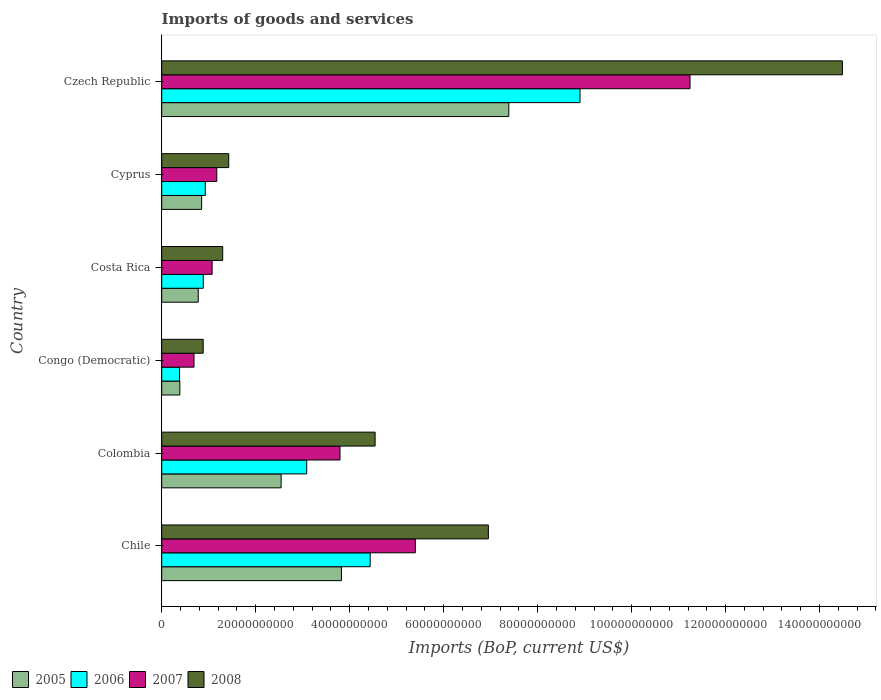How many different coloured bars are there?
Give a very brief answer. 4. How many groups of bars are there?
Give a very brief answer. 6. Are the number of bars per tick equal to the number of legend labels?
Ensure brevity in your answer.  Yes. How many bars are there on the 3rd tick from the top?
Your response must be concise. 4. What is the label of the 4th group of bars from the top?
Offer a very short reply. Congo (Democratic). What is the amount spent on imports in 2007 in Czech Republic?
Your response must be concise. 1.12e+11. Across all countries, what is the maximum amount spent on imports in 2006?
Give a very brief answer. 8.90e+1. Across all countries, what is the minimum amount spent on imports in 2006?
Provide a succinct answer. 3.80e+09. In which country was the amount spent on imports in 2006 maximum?
Provide a succinct answer. Czech Republic. In which country was the amount spent on imports in 2007 minimum?
Ensure brevity in your answer.  Congo (Democratic). What is the total amount spent on imports in 2008 in the graph?
Your response must be concise. 2.96e+11. What is the difference between the amount spent on imports in 2006 in Cyprus and that in Czech Republic?
Keep it short and to the point. -7.97e+1. What is the difference between the amount spent on imports in 2006 in Congo (Democratic) and the amount spent on imports in 2008 in Cyprus?
Your answer should be compact. -1.05e+1. What is the average amount spent on imports in 2008 per country?
Your answer should be very brief. 4.93e+1. What is the difference between the amount spent on imports in 2008 and amount spent on imports in 2005 in Colombia?
Offer a very short reply. 2.00e+1. In how many countries, is the amount spent on imports in 2008 greater than 136000000000 US$?
Keep it short and to the point. 1. What is the ratio of the amount spent on imports in 2008 in Chile to that in Congo (Democratic)?
Keep it short and to the point. 7.88. Is the amount spent on imports in 2006 in Costa Rica less than that in Czech Republic?
Make the answer very short. Yes. Is the difference between the amount spent on imports in 2008 in Chile and Costa Rica greater than the difference between the amount spent on imports in 2005 in Chile and Costa Rica?
Provide a short and direct response. Yes. What is the difference between the highest and the second highest amount spent on imports in 2006?
Provide a short and direct response. 4.47e+1. What is the difference between the highest and the lowest amount spent on imports in 2005?
Your response must be concise. 7.00e+1. Is the sum of the amount spent on imports in 2005 in Chile and Congo (Democratic) greater than the maximum amount spent on imports in 2008 across all countries?
Offer a terse response. No. What does the 1st bar from the top in Cyprus represents?
Ensure brevity in your answer.  2008. What does the 2nd bar from the bottom in Colombia represents?
Offer a very short reply. 2006. Is it the case that in every country, the sum of the amount spent on imports in 2006 and amount spent on imports in 2007 is greater than the amount spent on imports in 2008?
Provide a succinct answer. Yes. How many bars are there?
Your answer should be compact. 24. Are all the bars in the graph horizontal?
Your response must be concise. Yes. How many legend labels are there?
Your answer should be very brief. 4. How are the legend labels stacked?
Provide a short and direct response. Horizontal. What is the title of the graph?
Provide a succinct answer. Imports of goods and services. Does "1973" appear as one of the legend labels in the graph?
Ensure brevity in your answer.  No. What is the label or title of the X-axis?
Provide a short and direct response. Imports (BoP, current US$). What is the label or title of the Y-axis?
Provide a succinct answer. Country. What is the Imports (BoP, current US$) of 2005 in Chile?
Offer a terse response. 3.82e+1. What is the Imports (BoP, current US$) of 2006 in Chile?
Your answer should be compact. 4.44e+1. What is the Imports (BoP, current US$) in 2007 in Chile?
Keep it short and to the point. 5.40e+1. What is the Imports (BoP, current US$) in 2008 in Chile?
Give a very brief answer. 6.95e+1. What is the Imports (BoP, current US$) in 2005 in Colombia?
Give a very brief answer. 2.54e+1. What is the Imports (BoP, current US$) of 2006 in Colombia?
Ensure brevity in your answer.  3.09e+1. What is the Imports (BoP, current US$) in 2007 in Colombia?
Give a very brief answer. 3.79e+1. What is the Imports (BoP, current US$) in 2008 in Colombia?
Your answer should be compact. 4.54e+1. What is the Imports (BoP, current US$) of 2005 in Congo (Democratic)?
Offer a very short reply. 3.86e+09. What is the Imports (BoP, current US$) in 2006 in Congo (Democratic)?
Your answer should be compact. 3.80e+09. What is the Imports (BoP, current US$) of 2007 in Congo (Democratic)?
Make the answer very short. 6.87e+09. What is the Imports (BoP, current US$) in 2008 in Congo (Democratic)?
Make the answer very short. 8.83e+09. What is the Imports (BoP, current US$) in 2005 in Costa Rica?
Keep it short and to the point. 7.77e+09. What is the Imports (BoP, current US$) of 2006 in Costa Rica?
Keep it short and to the point. 8.85e+09. What is the Imports (BoP, current US$) of 2007 in Costa Rica?
Your answer should be compact. 1.07e+1. What is the Imports (BoP, current US$) of 2008 in Costa Rica?
Your response must be concise. 1.30e+1. What is the Imports (BoP, current US$) of 2005 in Cyprus?
Give a very brief answer. 8.50e+09. What is the Imports (BoP, current US$) of 2006 in Cyprus?
Your answer should be very brief. 9.27e+09. What is the Imports (BoP, current US$) in 2007 in Cyprus?
Your answer should be very brief. 1.17e+1. What is the Imports (BoP, current US$) in 2008 in Cyprus?
Your response must be concise. 1.43e+1. What is the Imports (BoP, current US$) in 2005 in Czech Republic?
Give a very brief answer. 7.39e+1. What is the Imports (BoP, current US$) in 2006 in Czech Republic?
Keep it short and to the point. 8.90e+1. What is the Imports (BoP, current US$) in 2007 in Czech Republic?
Offer a very short reply. 1.12e+11. What is the Imports (BoP, current US$) of 2008 in Czech Republic?
Provide a short and direct response. 1.45e+11. Across all countries, what is the maximum Imports (BoP, current US$) in 2005?
Provide a succinct answer. 7.39e+1. Across all countries, what is the maximum Imports (BoP, current US$) of 2006?
Provide a succinct answer. 8.90e+1. Across all countries, what is the maximum Imports (BoP, current US$) of 2007?
Make the answer very short. 1.12e+11. Across all countries, what is the maximum Imports (BoP, current US$) in 2008?
Offer a very short reply. 1.45e+11. Across all countries, what is the minimum Imports (BoP, current US$) in 2005?
Provide a short and direct response. 3.86e+09. Across all countries, what is the minimum Imports (BoP, current US$) in 2006?
Keep it short and to the point. 3.80e+09. Across all countries, what is the minimum Imports (BoP, current US$) in 2007?
Your answer should be compact. 6.87e+09. Across all countries, what is the minimum Imports (BoP, current US$) in 2008?
Your response must be concise. 8.83e+09. What is the total Imports (BoP, current US$) in 2005 in the graph?
Offer a terse response. 1.58e+11. What is the total Imports (BoP, current US$) of 2006 in the graph?
Offer a terse response. 1.86e+11. What is the total Imports (BoP, current US$) of 2007 in the graph?
Provide a succinct answer. 2.34e+11. What is the total Imports (BoP, current US$) in 2008 in the graph?
Provide a short and direct response. 2.96e+11. What is the difference between the Imports (BoP, current US$) of 2005 in Chile and that in Colombia?
Your response must be concise. 1.28e+1. What is the difference between the Imports (BoP, current US$) in 2006 in Chile and that in Colombia?
Provide a succinct answer. 1.35e+1. What is the difference between the Imports (BoP, current US$) of 2007 in Chile and that in Colombia?
Offer a terse response. 1.60e+1. What is the difference between the Imports (BoP, current US$) in 2008 in Chile and that in Colombia?
Your response must be concise. 2.41e+1. What is the difference between the Imports (BoP, current US$) in 2005 in Chile and that in Congo (Democratic)?
Offer a terse response. 3.44e+1. What is the difference between the Imports (BoP, current US$) in 2006 in Chile and that in Congo (Democratic)?
Your response must be concise. 4.06e+1. What is the difference between the Imports (BoP, current US$) of 2007 in Chile and that in Congo (Democratic)?
Offer a very short reply. 4.71e+1. What is the difference between the Imports (BoP, current US$) of 2008 in Chile and that in Congo (Democratic)?
Your response must be concise. 6.07e+1. What is the difference between the Imports (BoP, current US$) of 2005 in Chile and that in Costa Rica?
Your response must be concise. 3.05e+1. What is the difference between the Imports (BoP, current US$) of 2006 in Chile and that in Costa Rica?
Offer a very short reply. 3.55e+1. What is the difference between the Imports (BoP, current US$) in 2007 in Chile and that in Costa Rica?
Ensure brevity in your answer.  4.33e+1. What is the difference between the Imports (BoP, current US$) of 2008 in Chile and that in Costa Rica?
Ensure brevity in your answer.  5.65e+1. What is the difference between the Imports (BoP, current US$) in 2005 in Chile and that in Cyprus?
Offer a terse response. 2.98e+1. What is the difference between the Imports (BoP, current US$) of 2006 in Chile and that in Cyprus?
Provide a succinct answer. 3.51e+1. What is the difference between the Imports (BoP, current US$) of 2007 in Chile and that in Cyprus?
Your response must be concise. 4.23e+1. What is the difference between the Imports (BoP, current US$) in 2008 in Chile and that in Cyprus?
Your answer should be compact. 5.53e+1. What is the difference between the Imports (BoP, current US$) in 2005 in Chile and that in Czech Republic?
Your answer should be compact. -3.56e+1. What is the difference between the Imports (BoP, current US$) of 2006 in Chile and that in Czech Republic?
Your answer should be very brief. -4.47e+1. What is the difference between the Imports (BoP, current US$) of 2007 in Chile and that in Czech Republic?
Give a very brief answer. -5.85e+1. What is the difference between the Imports (BoP, current US$) of 2008 in Chile and that in Czech Republic?
Your answer should be compact. -7.54e+1. What is the difference between the Imports (BoP, current US$) of 2005 in Colombia and that in Congo (Democratic)?
Provide a short and direct response. 2.16e+1. What is the difference between the Imports (BoP, current US$) of 2006 in Colombia and that in Congo (Democratic)?
Your answer should be very brief. 2.71e+1. What is the difference between the Imports (BoP, current US$) in 2007 in Colombia and that in Congo (Democratic)?
Your answer should be compact. 3.11e+1. What is the difference between the Imports (BoP, current US$) in 2008 in Colombia and that in Congo (Democratic)?
Provide a succinct answer. 3.66e+1. What is the difference between the Imports (BoP, current US$) in 2005 in Colombia and that in Costa Rica?
Your answer should be compact. 1.76e+1. What is the difference between the Imports (BoP, current US$) in 2006 in Colombia and that in Costa Rica?
Offer a terse response. 2.20e+1. What is the difference between the Imports (BoP, current US$) of 2007 in Colombia and that in Costa Rica?
Give a very brief answer. 2.72e+1. What is the difference between the Imports (BoP, current US$) of 2008 in Colombia and that in Costa Rica?
Give a very brief answer. 3.24e+1. What is the difference between the Imports (BoP, current US$) in 2005 in Colombia and that in Cyprus?
Ensure brevity in your answer.  1.69e+1. What is the difference between the Imports (BoP, current US$) in 2006 in Colombia and that in Cyprus?
Keep it short and to the point. 2.16e+1. What is the difference between the Imports (BoP, current US$) of 2007 in Colombia and that in Cyprus?
Your answer should be very brief. 2.62e+1. What is the difference between the Imports (BoP, current US$) of 2008 in Colombia and that in Cyprus?
Your response must be concise. 3.12e+1. What is the difference between the Imports (BoP, current US$) in 2005 in Colombia and that in Czech Republic?
Offer a terse response. -4.85e+1. What is the difference between the Imports (BoP, current US$) of 2006 in Colombia and that in Czech Republic?
Your response must be concise. -5.82e+1. What is the difference between the Imports (BoP, current US$) in 2007 in Colombia and that in Czech Republic?
Your response must be concise. -7.45e+1. What is the difference between the Imports (BoP, current US$) of 2008 in Colombia and that in Czech Republic?
Offer a very short reply. -9.95e+1. What is the difference between the Imports (BoP, current US$) of 2005 in Congo (Democratic) and that in Costa Rica?
Your answer should be compact. -3.91e+09. What is the difference between the Imports (BoP, current US$) in 2006 in Congo (Democratic) and that in Costa Rica?
Your response must be concise. -5.05e+09. What is the difference between the Imports (BoP, current US$) in 2007 in Congo (Democratic) and that in Costa Rica?
Your answer should be compact. -3.85e+09. What is the difference between the Imports (BoP, current US$) in 2008 in Congo (Democratic) and that in Costa Rica?
Provide a succinct answer. -4.15e+09. What is the difference between the Imports (BoP, current US$) in 2005 in Congo (Democratic) and that in Cyprus?
Make the answer very short. -4.64e+09. What is the difference between the Imports (BoP, current US$) in 2006 in Congo (Democratic) and that in Cyprus?
Offer a very short reply. -5.48e+09. What is the difference between the Imports (BoP, current US$) of 2007 in Congo (Democratic) and that in Cyprus?
Provide a short and direct response. -4.85e+09. What is the difference between the Imports (BoP, current US$) of 2008 in Congo (Democratic) and that in Cyprus?
Your answer should be compact. -5.44e+09. What is the difference between the Imports (BoP, current US$) of 2005 in Congo (Democratic) and that in Czech Republic?
Provide a short and direct response. -7.00e+1. What is the difference between the Imports (BoP, current US$) in 2006 in Congo (Democratic) and that in Czech Republic?
Keep it short and to the point. -8.52e+1. What is the difference between the Imports (BoP, current US$) in 2007 in Congo (Democratic) and that in Czech Republic?
Your answer should be compact. -1.06e+11. What is the difference between the Imports (BoP, current US$) of 2008 in Congo (Democratic) and that in Czech Republic?
Provide a succinct answer. -1.36e+11. What is the difference between the Imports (BoP, current US$) of 2005 in Costa Rica and that in Cyprus?
Provide a short and direct response. -7.27e+08. What is the difference between the Imports (BoP, current US$) in 2006 in Costa Rica and that in Cyprus?
Your answer should be very brief. -4.28e+08. What is the difference between the Imports (BoP, current US$) in 2007 in Costa Rica and that in Cyprus?
Your response must be concise. -9.93e+08. What is the difference between the Imports (BoP, current US$) in 2008 in Costa Rica and that in Cyprus?
Give a very brief answer. -1.29e+09. What is the difference between the Imports (BoP, current US$) of 2005 in Costa Rica and that in Czech Republic?
Your answer should be very brief. -6.61e+1. What is the difference between the Imports (BoP, current US$) of 2006 in Costa Rica and that in Czech Republic?
Provide a succinct answer. -8.02e+1. What is the difference between the Imports (BoP, current US$) of 2007 in Costa Rica and that in Czech Republic?
Offer a very short reply. -1.02e+11. What is the difference between the Imports (BoP, current US$) of 2008 in Costa Rica and that in Czech Republic?
Provide a succinct answer. -1.32e+11. What is the difference between the Imports (BoP, current US$) in 2005 in Cyprus and that in Czech Republic?
Your answer should be very brief. -6.54e+1. What is the difference between the Imports (BoP, current US$) in 2006 in Cyprus and that in Czech Republic?
Give a very brief answer. -7.97e+1. What is the difference between the Imports (BoP, current US$) in 2007 in Cyprus and that in Czech Republic?
Give a very brief answer. -1.01e+11. What is the difference between the Imports (BoP, current US$) in 2008 in Cyprus and that in Czech Republic?
Keep it short and to the point. -1.31e+11. What is the difference between the Imports (BoP, current US$) of 2005 in Chile and the Imports (BoP, current US$) of 2006 in Colombia?
Your answer should be very brief. 7.40e+09. What is the difference between the Imports (BoP, current US$) in 2005 in Chile and the Imports (BoP, current US$) in 2007 in Colombia?
Offer a very short reply. 3.07e+08. What is the difference between the Imports (BoP, current US$) in 2005 in Chile and the Imports (BoP, current US$) in 2008 in Colombia?
Ensure brevity in your answer.  -7.17e+09. What is the difference between the Imports (BoP, current US$) of 2006 in Chile and the Imports (BoP, current US$) of 2007 in Colombia?
Provide a short and direct response. 6.42e+09. What is the difference between the Imports (BoP, current US$) in 2006 in Chile and the Imports (BoP, current US$) in 2008 in Colombia?
Your answer should be very brief. -1.05e+09. What is the difference between the Imports (BoP, current US$) of 2007 in Chile and the Imports (BoP, current US$) of 2008 in Colombia?
Your response must be concise. 8.57e+09. What is the difference between the Imports (BoP, current US$) of 2005 in Chile and the Imports (BoP, current US$) of 2006 in Congo (Democratic)?
Provide a short and direct response. 3.45e+1. What is the difference between the Imports (BoP, current US$) in 2005 in Chile and the Imports (BoP, current US$) in 2007 in Congo (Democratic)?
Make the answer very short. 3.14e+1. What is the difference between the Imports (BoP, current US$) in 2005 in Chile and the Imports (BoP, current US$) in 2008 in Congo (Democratic)?
Offer a terse response. 2.94e+1. What is the difference between the Imports (BoP, current US$) of 2006 in Chile and the Imports (BoP, current US$) of 2007 in Congo (Democratic)?
Provide a short and direct response. 3.75e+1. What is the difference between the Imports (BoP, current US$) of 2006 in Chile and the Imports (BoP, current US$) of 2008 in Congo (Democratic)?
Offer a terse response. 3.55e+1. What is the difference between the Imports (BoP, current US$) of 2007 in Chile and the Imports (BoP, current US$) of 2008 in Congo (Democratic)?
Your response must be concise. 4.52e+1. What is the difference between the Imports (BoP, current US$) in 2005 in Chile and the Imports (BoP, current US$) in 2006 in Costa Rica?
Provide a short and direct response. 2.94e+1. What is the difference between the Imports (BoP, current US$) in 2005 in Chile and the Imports (BoP, current US$) in 2007 in Costa Rica?
Ensure brevity in your answer.  2.75e+1. What is the difference between the Imports (BoP, current US$) of 2005 in Chile and the Imports (BoP, current US$) of 2008 in Costa Rica?
Your response must be concise. 2.53e+1. What is the difference between the Imports (BoP, current US$) of 2006 in Chile and the Imports (BoP, current US$) of 2007 in Costa Rica?
Offer a terse response. 3.36e+1. What is the difference between the Imports (BoP, current US$) in 2006 in Chile and the Imports (BoP, current US$) in 2008 in Costa Rica?
Offer a very short reply. 3.14e+1. What is the difference between the Imports (BoP, current US$) in 2007 in Chile and the Imports (BoP, current US$) in 2008 in Costa Rica?
Your response must be concise. 4.10e+1. What is the difference between the Imports (BoP, current US$) in 2005 in Chile and the Imports (BoP, current US$) in 2006 in Cyprus?
Offer a terse response. 2.90e+1. What is the difference between the Imports (BoP, current US$) of 2005 in Chile and the Imports (BoP, current US$) of 2007 in Cyprus?
Keep it short and to the point. 2.65e+1. What is the difference between the Imports (BoP, current US$) of 2005 in Chile and the Imports (BoP, current US$) of 2008 in Cyprus?
Offer a terse response. 2.40e+1. What is the difference between the Imports (BoP, current US$) in 2006 in Chile and the Imports (BoP, current US$) in 2007 in Cyprus?
Your answer should be compact. 3.26e+1. What is the difference between the Imports (BoP, current US$) of 2006 in Chile and the Imports (BoP, current US$) of 2008 in Cyprus?
Make the answer very short. 3.01e+1. What is the difference between the Imports (BoP, current US$) of 2007 in Chile and the Imports (BoP, current US$) of 2008 in Cyprus?
Your response must be concise. 3.97e+1. What is the difference between the Imports (BoP, current US$) in 2005 in Chile and the Imports (BoP, current US$) in 2006 in Czech Republic?
Ensure brevity in your answer.  -5.08e+1. What is the difference between the Imports (BoP, current US$) in 2005 in Chile and the Imports (BoP, current US$) in 2007 in Czech Republic?
Your response must be concise. -7.42e+1. What is the difference between the Imports (BoP, current US$) of 2005 in Chile and the Imports (BoP, current US$) of 2008 in Czech Republic?
Provide a succinct answer. -1.07e+11. What is the difference between the Imports (BoP, current US$) in 2006 in Chile and the Imports (BoP, current US$) in 2007 in Czech Republic?
Your answer should be very brief. -6.81e+1. What is the difference between the Imports (BoP, current US$) in 2006 in Chile and the Imports (BoP, current US$) in 2008 in Czech Republic?
Your answer should be very brief. -1.01e+11. What is the difference between the Imports (BoP, current US$) of 2007 in Chile and the Imports (BoP, current US$) of 2008 in Czech Republic?
Your response must be concise. -9.09e+1. What is the difference between the Imports (BoP, current US$) of 2005 in Colombia and the Imports (BoP, current US$) of 2006 in Congo (Democratic)?
Your answer should be very brief. 2.16e+1. What is the difference between the Imports (BoP, current US$) of 2005 in Colombia and the Imports (BoP, current US$) of 2007 in Congo (Democratic)?
Give a very brief answer. 1.85e+1. What is the difference between the Imports (BoP, current US$) in 2005 in Colombia and the Imports (BoP, current US$) in 2008 in Congo (Democratic)?
Make the answer very short. 1.66e+1. What is the difference between the Imports (BoP, current US$) of 2006 in Colombia and the Imports (BoP, current US$) of 2007 in Congo (Democratic)?
Provide a succinct answer. 2.40e+1. What is the difference between the Imports (BoP, current US$) of 2006 in Colombia and the Imports (BoP, current US$) of 2008 in Congo (Democratic)?
Offer a very short reply. 2.20e+1. What is the difference between the Imports (BoP, current US$) in 2007 in Colombia and the Imports (BoP, current US$) in 2008 in Congo (Democratic)?
Give a very brief answer. 2.91e+1. What is the difference between the Imports (BoP, current US$) of 2005 in Colombia and the Imports (BoP, current US$) of 2006 in Costa Rica?
Offer a terse response. 1.66e+1. What is the difference between the Imports (BoP, current US$) in 2005 in Colombia and the Imports (BoP, current US$) in 2007 in Costa Rica?
Provide a succinct answer. 1.47e+1. What is the difference between the Imports (BoP, current US$) in 2005 in Colombia and the Imports (BoP, current US$) in 2008 in Costa Rica?
Offer a very short reply. 1.24e+1. What is the difference between the Imports (BoP, current US$) in 2006 in Colombia and the Imports (BoP, current US$) in 2007 in Costa Rica?
Your response must be concise. 2.01e+1. What is the difference between the Imports (BoP, current US$) in 2006 in Colombia and the Imports (BoP, current US$) in 2008 in Costa Rica?
Offer a very short reply. 1.79e+1. What is the difference between the Imports (BoP, current US$) of 2007 in Colombia and the Imports (BoP, current US$) of 2008 in Costa Rica?
Offer a terse response. 2.50e+1. What is the difference between the Imports (BoP, current US$) of 2005 in Colombia and the Imports (BoP, current US$) of 2006 in Cyprus?
Keep it short and to the point. 1.61e+1. What is the difference between the Imports (BoP, current US$) in 2005 in Colombia and the Imports (BoP, current US$) in 2007 in Cyprus?
Provide a succinct answer. 1.37e+1. What is the difference between the Imports (BoP, current US$) of 2005 in Colombia and the Imports (BoP, current US$) of 2008 in Cyprus?
Make the answer very short. 1.11e+1. What is the difference between the Imports (BoP, current US$) of 2006 in Colombia and the Imports (BoP, current US$) of 2007 in Cyprus?
Ensure brevity in your answer.  1.91e+1. What is the difference between the Imports (BoP, current US$) of 2006 in Colombia and the Imports (BoP, current US$) of 2008 in Cyprus?
Offer a terse response. 1.66e+1. What is the difference between the Imports (BoP, current US$) in 2007 in Colombia and the Imports (BoP, current US$) in 2008 in Cyprus?
Ensure brevity in your answer.  2.37e+1. What is the difference between the Imports (BoP, current US$) of 2005 in Colombia and the Imports (BoP, current US$) of 2006 in Czech Republic?
Your answer should be compact. -6.36e+1. What is the difference between the Imports (BoP, current US$) of 2005 in Colombia and the Imports (BoP, current US$) of 2007 in Czech Republic?
Make the answer very short. -8.70e+1. What is the difference between the Imports (BoP, current US$) of 2005 in Colombia and the Imports (BoP, current US$) of 2008 in Czech Republic?
Ensure brevity in your answer.  -1.19e+11. What is the difference between the Imports (BoP, current US$) of 2006 in Colombia and the Imports (BoP, current US$) of 2007 in Czech Republic?
Provide a short and direct response. -8.16e+1. What is the difference between the Imports (BoP, current US$) of 2006 in Colombia and the Imports (BoP, current US$) of 2008 in Czech Republic?
Your answer should be compact. -1.14e+11. What is the difference between the Imports (BoP, current US$) in 2007 in Colombia and the Imports (BoP, current US$) in 2008 in Czech Republic?
Keep it short and to the point. -1.07e+11. What is the difference between the Imports (BoP, current US$) of 2005 in Congo (Democratic) and the Imports (BoP, current US$) of 2006 in Costa Rica?
Make the answer very short. -4.99e+09. What is the difference between the Imports (BoP, current US$) in 2005 in Congo (Democratic) and the Imports (BoP, current US$) in 2007 in Costa Rica?
Offer a very short reply. -6.87e+09. What is the difference between the Imports (BoP, current US$) in 2005 in Congo (Democratic) and the Imports (BoP, current US$) in 2008 in Costa Rica?
Give a very brief answer. -9.12e+09. What is the difference between the Imports (BoP, current US$) of 2006 in Congo (Democratic) and the Imports (BoP, current US$) of 2007 in Costa Rica?
Provide a succinct answer. -6.93e+09. What is the difference between the Imports (BoP, current US$) of 2006 in Congo (Democratic) and the Imports (BoP, current US$) of 2008 in Costa Rica?
Offer a terse response. -9.18e+09. What is the difference between the Imports (BoP, current US$) in 2007 in Congo (Democratic) and the Imports (BoP, current US$) in 2008 in Costa Rica?
Your response must be concise. -6.10e+09. What is the difference between the Imports (BoP, current US$) in 2005 in Congo (Democratic) and the Imports (BoP, current US$) in 2006 in Cyprus?
Your answer should be very brief. -5.41e+09. What is the difference between the Imports (BoP, current US$) of 2005 in Congo (Democratic) and the Imports (BoP, current US$) of 2007 in Cyprus?
Your answer should be very brief. -7.86e+09. What is the difference between the Imports (BoP, current US$) of 2005 in Congo (Democratic) and the Imports (BoP, current US$) of 2008 in Cyprus?
Keep it short and to the point. -1.04e+1. What is the difference between the Imports (BoP, current US$) of 2006 in Congo (Democratic) and the Imports (BoP, current US$) of 2007 in Cyprus?
Provide a short and direct response. -7.92e+09. What is the difference between the Imports (BoP, current US$) in 2006 in Congo (Democratic) and the Imports (BoP, current US$) in 2008 in Cyprus?
Your answer should be very brief. -1.05e+1. What is the difference between the Imports (BoP, current US$) of 2007 in Congo (Democratic) and the Imports (BoP, current US$) of 2008 in Cyprus?
Ensure brevity in your answer.  -7.39e+09. What is the difference between the Imports (BoP, current US$) in 2005 in Congo (Democratic) and the Imports (BoP, current US$) in 2006 in Czech Republic?
Provide a short and direct response. -8.52e+1. What is the difference between the Imports (BoP, current US$) in 2005 in Congo (Democratic) and the Imports (BoP, current US$) in 2007 in Czech Republic?
Your answer should be very brief. -1.09e+11. What is the difference between the Imports (BoP, current US$) in 2005 in Congo (Democratic) and the Imports (BoP, current US$) in 2008 in Czech Republic?
Give a very brief answer. -1.41e+11. What is the difference between the Imports (BoP, current US$) in 2006 in Congo (Democratic) and the Imports (BoP, current US$) in 2007 in Czech Republic?
Make the answer very short. -1.09e+11. What is the difference between the Imports (BoP, current US$) of 2006 in Congo (Democratic) and the Imports (BoP, current US$) of 2008 in Czech Republic?
Provide a succinct answer. -1.41e+11. What is the difference between the Imports (BoP, current US$) of 2007 in Congo (Democratic) and the Imports (BoP, current US$) of 2008 in Czech Republic?
Your response must be concise. -1.38e+11. What is the difference between the Imports (BoP, current US$) of 2005 in Costa Rica and the Imports (BoP, current US$) of 2006 in Cyprus?
Keep it short and to the point. -1.50e+09. What is the difference between the Imports (BoP, current US$) in 2005 in Costa Rica and the Imports (BoP, current US$) in 2007 in Cyprus?
Your answer should be very brief. -3.95e+09. What is the difference between the Imports (BoP, current US$) of 2005 in Costa Rica and the Imports (BoP, current US$) of 2008 in Cyprus?
Your answer should be compact. -6.49e+09. What is the difference between the Imports (BoP, current US$) of 2006 in Costa Rica and the Imports (BoP, current US$) of 2007 in Cyprus?
Ensure brevity in your answer.  -2.88e+09. What is the difference between the Imports (BoP, current US$) in 2006 in Costa Rica and the Imports (BoP, current US$) in 2008 in Cyprus?
Provide a short and direct response. -5.42e+09. What is the difference between the Imports (BoP, current US$) in 2007 in Costa Rica and the Imports (BoP, current US$) in 2008 in Cyprus?
Keep it short and to the point. -3.54e+09. What is the difference between the Imports (BoP, current US$) in 2005 in Costa Rica and the Imports (BoP, current US$) in 2006 in Czech Republic?
Offer a very short reply. -8.13e+1. What is the difference between the Imports (BoP, current US$) in 2005 in Costa Rica and the Imports (BoP, current US$) in 2007 in Czech Republic?
Your answer should be compact. -1.05e+11. What is the difference between the Imports (BoP, current US$) of 2005 in Costa Rica and the Imports (BoP, current US$) of 2008 in Czech Republic?
Give a very brief answer. -1.37e+11. What is the difference between the Imports (BoP, current US$) in 2006 in Costa Rica and the Imports (BoP, current US$) in 2007 in Czech Republic?
Provide a short and direct response. -1.04e+11. What is the difference between the Imports (BoP, current US$) of 2006 in Costa Rica and the Imports (BoP, current US$) of 2008 in Czech Republic?
Keep it short and to the point. -1.36e+11. What is the difference between the Imports (BoP, current US$) of 2007 in Costa Rica and the Imports (BoP, current US$) of 2008 in Czech Republic?
Make the answer very short. -1.34e+11. What is the difference between the Imports (BoP, current US$) of 2005 in Cyprus and the Imports (BoP, current US$) of 2006 in Czech Republic?
Give a very brief answer. -8.05e+1. What is the difference between the Imports (BoP, current US$) in 2005 in Cyprus and the Imports (BoP, current US$) in 2007 in Czech Republic?
Provide a succinct answer. -1.04e+11. What is the difference between the Imports (BoP, current US$) in 2005 in Cyprus and the Imports (BoP, current US$) in 2008 in Czech Republic?
Offer a terse response. -1.36e+11. What is the difference between the Imports (BoP, current US$) of 2006 in Cyprus and the Imports (BoP, current US$) of 2007 in Czech Republic?
Your answer should be compact. -1.03e+11. What is the difference between the Imports (BoP, current US$) of 2006 in Cyprus and the Imports (BoP, current US$) of 2008 in Czech Republic?
Give a very brief answer. -1.36e+11. What is the difference between the Imports (BoP, current US$) of 2007 in Cyprus and the Imports (BoP, current US$) of 2008 in Czech Republic?
Make the answer very short. -1.33e+11. What is the average Imports (BoP, current US$) of 2005 per country?
Provide a succinct answer. 2.63e+1. What is the average Imports (BoP, current US$) in 2006 per country?
Offer a very short reply. 3.10e+1. What is the average Imports (BoP, current US$) of 2007 per country?
Your answer should be very brief. 3.89e+1. What is the average Imports (BoP, current US$) in 2008 per country?
Make the answer very short. 4.93e+1. What is the difference between the Imports (BoP, current US$) in 2005 and Imports (BoP, current US$) in 2006 in Chile?
Your answer should be compact. -6.11e+09. What is the difference between the Imports (BoP, current US$) in 2005 and Imports (BoP, current US$) in 2007 in Chile?
Give a very brief answer. -1.57e+1. What is the difference between the Imports (BoP, current US$) in 2005 and Imports (BoP, current US$) in 2008 in Chile?
Make the answer very short. -3.13e+1. What is the difference between the Imports (BoP, current US$) in 2006 and Imports (BoP, current US$) in 2007 in Chile?
Your answer should be very brief. -9.62e+09. What is the difference between the Imports (BoP, current US$) of 2006 and Imports (BoP, current US$) of 2008 in Chile?
Keep it short and to the point. -2.52e+1. What is the difference between the Imports (BoP, current US$) in 2007 and Imports (BoP, current US$) in 2008 in Chile?
Provide a succinct answer. -1.55e+1. What is the difference between the Imports (BoP, current US$) in 2005 and Imports (BoP, current US$) in 2006 in Colombia?
Offer a very short reply. -5.44e+09. What is the difference between the Imports (BoP, current US$) in 2005 and Imports (BoP, current US$) in 2007 in Colombia?
Your answer should be very brief. -1.25e+1. What is the difference between the Imports (BoP, current US$) in 2005 and Imports (BoP, current US$) in 2008 in Colombia?
Give a very brief answer. -2.00e+1. What is the difference between the Imports (BoP, current US$) of 2006 and Imports (BoP, current US$) of 2007 in Colombia?
Your response must be concise. -7.09e+09. What is the difference between the Imports (BoP, current US$) of 2006 and Imports (BoP, current US$) of 2008 in Colombia?
Provide a short and direct response. -1.46e+1. What is the difference between the Imports (BoP, current US$) in 2007 and Imports (BoP, current US$) in 2008 in Colombia?
Make the answer very short. -7.47e+09. What is the difference between the Imports (BoP, current US$) of 2005 and Imports (BoP, current US$) of 2006 in Congo (Democratic)?
Provide a short and direct response. 6.22e+07. What is the difference between the Imports (BoP, current US$) of 2005 and Imports (BoP, current US$) of 2007 in Congo (Democratic)?
Keep it short and to the point. -3.02e+09. What is the difference between the Imports (BoP, current US$) of 2005 and Imports (BoP, current US$) of 2008 in Congo (Democratic)?
Provide a short and direct response. -4.97e+09. What is the difference between the Imports (BoP, current US$) in 2006 and Imports (BoP, current US$) in 2007 in Congo (Democratic)?
Your answer should be compact. -3.08e+09. What is the difference between the Imports (BoP, current US$) of 2006 and Imports (BoP, current US$) of 2008 in Congo (Democratic)?
Offer a very short reply. -5.03e+09. What is the difference between the Imports (BoP, current US$) of 2007 and Imports (BoP, current US$) of 2008 in Congo (Democratic)?
Your answer should be very brief. -1.95e+09. What is the difference between the Imports (BoP, current US$) of 2005 and Imports (BoP, current US$) of 2006 in Costa Rica?
Provide a succinct answer. -1.07e+09. What is the difference between the Imports (BoP, current US$) in 2005 and Imports (BoP, current US$) in 2007 in Costa Rica?
Your response must be concise. -2.96e+09. What is the difference between the Imports (BoP, current US$) of 2005 and Imports (BoP, current US$) of 2008 in Costa Rica?
Your answer should be compact. -5.21e+09. What is the difference between the Imports (BoP, current US$) of 2006 and Imports (BoP, current US$) of 2007 in Costa Rica?
Keep it short and to the point. -1.88e+09. What is the difference between the Imports (BoP, current US$) of 2006 and Imports (BoP, current US$) of 2008 in Costa Rica?
Offer a very short reply. -4.13e+09. What is the difference between the Imports (BoP, current US$) in 2007 and Imports (BoP, current US$) in 2008 in Costa Rica?
Keep it short and to the point. -2.25e+09. What is the difference between the Imports (BoP, current US$) in 2005 and Imports (BoP, current US$) in 2006 in Cyprus?
Offer a terse response. -7.76e+08. What is the difference between the Imports (BoP, current US$) of 2005 and Imports (BoP, current US$) of 2007 in Cyprus?
Your answer should be very brief. -3.22e+09. What is the difference between the Imports (BoP, current US$) in 2005 and Imports (BoP, current US$) in 2008 in Cyprus?
Your answer should be very brief. -5.77e+09. What is the difference between the Imports (BoP, current US$) of 2006 and Imports (BoP, current US$) of 2007 in Cyprus?
Keep it short and to the point. -2.45e+09. What is the difference between the Imports (BoP, current US$) in 2006 and Imports (BoP, current US$) in 2008 in Cyprus?
Keep it short and to the point. -4.99e+09. What is the difference between the Imports (BoP, current US$) of 2007 and Imports (BoP, current US$) of 2008 in Cyprus?
Offer a very short reply. -2.54e+09. What is the difference between the Imports (BoP, current US$) of 2005 and Imports (BoP, current US$) of 2006 in Czech Republic?
Offer a very short reply. -1.52e+1. What is the difference between the Imports (BoP, current US$) in 2005 and Imports (BoP, current US$) in 2007 in Czech Republic?
Provide a short and direct response. -3.86e+1. What is the difference between the Imports (BoP, current US$) of 2005 and Imports (BoP, current US$) of 2008 in Czech Republic?
Ensure brevity in your answer.  -7.10e+1. What is the difference between the Imports (BoP, current US$) in 2006 and Imports (BoP, current US$) in 2007 in Czech Republic?
Your response must be concise. -2.34e+1. What is the difference between the Imports (BoP, current US$) of 2006 and Imports (BoP, current US$) of 2008 in Czech Republic?
Ensure brevity in your answer.  -5.58e+1. What is the difference between the Imports (BoP, current US$) of 2007 and Imports (BoP, current US$) of 2008 in Czech Republic?
Keep it short and to the point. -3.24e+1. What is the ratio of the Imports (BoP, current US$) of 2005 in Chile to that in Colombia?
Your answer should be compact. 1.51. What is the ratio of the Imports (BoP, current US$) in 2006 in Chile to that in Colombia?
Offer a terse response. 1.44. What is the ratio of the Imports (BoP, current US$) in 2007 in Chile to that in Colombia?
Keep it short and to the point. 1.42. What is the ratio of the Imports (BoP, current US$) in 2008 in Chile to that in Colombia?
Provide a short and direct response. 1.53. What is the ratio of the Imports (BoP, current US$) of 2005 in Chile to that in Congo (Democratic)?
Offer a terse response. 9.91. What is the ratio of the Imports (BoP, current US$) in 2006 in Chile to that in Congo (Democratic)?
Ensure brevity in your answer.  11.68. What is the ratio of the Imports (BoP, current US$) in 2007 in Chile to that in Congo (Democratic)?
Provide a succinct answer. 7.85. What is the ratio of the Imports (BoP, current US$) in 2008 in Chile to that in Congo (Democratic)?
Your answer should be very brief. 7.88. What is the ratio of the Imports (BoP, current US$) in 2005 in Chile to that in Costa Rica?
Your response must be concise. 4.92. What is the ratio of the Imports (BoP, current US$) of 2006 in Chile to that in Costa Rica?
Your response must be concise. 5.01. What is the ratio of the Imports (BoP, current US$) in 2007 in Chile to that in Costa Rica?
Your answer should be compact. 5.03. What is the ratio of the Imports (BoP, current US$) of 2008 in Chile to that in Costa Rica?
Ensure brevity in your answer.  5.36. What is the ratio of the Imports (BoP, current US$) in 2005 in Chile to that in Cyprus?
Your answer should be very brief. 4.5. What is the ratio of the Imports (BoP, current US$) of 2006 in Chile to that in Cyprus?
Give a very brief answer. 4.78. What is the ratio of the Imports (BoP, current US$) of 2007 in Chile to that in Cyprus?
Make the answer very short. 4.61. What is the ratio of the Imports (BoP, current US$) of 2008 in Chile to that in Cyprus?
Your response must be concise. 4.87. What is the ratio of the Imports (BoP, current US$) in 2005 in Chile to that in Czech Republic?
Provide a short and direct response. 0.52. What is the ratio of the Imports (BoP, current US$) of 2006 in Chile to that in Czech Republic?
Offer a very short reply. 0.5. What is the ratio of the Imports (BoP, current US$) of 2007 in Chile to that in Czech Republic?
Offer a terse response. 0.48. What is the ratio of the Imports (BoP, current US$) in 2008 in Chile to that in Czech Republic?
Provide a succinct answer. 0.48. What is the ratio of the Imports (BoP, current US$) of 2005 in Colombia to that in Congo (Democratic)?
Make the answer very short. 6.58. What is the ratio of the Imports (BoP, current US$) in 2006 in Colombia to that in Congo (Democratic)?
Make the answer very short. 8.12. What is the ratio of the Imports (BoP, current US$) in 2007 in Colombia to that in Congo (Democratic)?
Make the answer very short. 5.52. What is the ratio of the Imports (BoP, current US$) of 2008 in Colombia to that in Congo (Democratic)?
Make the answer very short. 5.15. What is the ratio of the Imports (BoP, current US$) of 2005 in Colombia to that in Costa Rica?
Provide a short and direct response. 3.27. What is the ratio of the Imports (BoP, current US$) in 2006 in Colombia to that in Costa Rica?
Offer a very short reply. 3.49. What is the ratio of the Imports (BoP, current US$) of 2007 in Colombia to that in Costa Rica?
Your response must be concise. 3.54. What is the ratio of the Imports (BoP, current US$) of 2008 in Colombia to that in Costa Rica?
Provide a succinct answer. 3.5. What is the ratio of the Imports (BoP, current US$) of 2005 in Colombia to that in Cyprus?
Your response must be concise. 2.99. What is the ratio of the Imports (BoP, current US$) of 2006 in Colombia to that in Cyprus?
Give a very brief answer. 3.33. What is the ratio of the Imports (BoP, current US$) in 2007 in Colombia to that in Cyprus?
Offer a terse response. 3.24. What is the ratio of the Imports (BoP, current US$) of 2008 in Colombia to that in Cyprus?
Give a very brief answer. 3.18. What is the ratio of the Imports (BoP, current US$) in 2005 in Colombia to that in Czech Republic?
Your answer should be very brief. 0.34. What is the ratio of the Imports (BoP, current US$) of 2006 in Colombia to that in Czech Republic?
Provide a short and direct response. 0.35. What is the ratio of the Imports (BoP, current US$) of 2007 in Colombia to that in Czech Republic?
Make the answer very short. 0.34. What is the ratio of the Imports (BoP, current US$) in 2008 in Colombia to that in Czech Republic?
Make the answer very short. 0.31. What is the ratio of the Imports (BoP, current US$) of 2005 in Congo (Democratic) to that in Costa Rica?
Make the answer very short. 0.5. What is the ratio of the Imports (BoP, current US$) in 2006 in Congo (Democratic) to that in Costa Rica?
Provide a short and direct response. 0.43. What is the ratio of the Imports (BoP, current US$) in 2007 in Congo (Democratic) to that in Costa Rica?
Keep it short and to the point. 0.64. What is the ratio of the Imports (BoP, current US$) in 2008 in Congo (Democratic) to that in Costa Rica?
Offer a very short reply. 0.68. What is the ratio of the Imports (BoP, current US$) in 2005 in Congo (Democratic) to that in Cyprus?
Offer a very short reply. 0.45. What is the ratio of the Imports (BoP, current US$) of 2006 in Congo (Democratic) to that in Cyprus?
Give a very brief answer. 0.41. What is the ratio of the Imports (BoP, current US$) of 2007 in Congo (Democratic) to that in Cyprus?
Ensure brevity in your answer.  0.59. What is the ratio of the Imports (BoP, current US$) of 2008 in Congo (Democratic) to that in Cyprus?
Provide a short and direct response. 0.62. What is the ratio of the Imports (BoP, current US$) of 2005 in Congo (Democratic) to that in Czech Republic?
Your response must be concise. 0.05. What is the ratio of the Imports (BoP, current US$) of 2006 in Congo (Democratic) to that in Czech Republic?
Give a very brief answer. 0.04. What is the ratio of the Imports (BoP, current US$) in 2007 in Congo (Democratic) to that in Czech Republic?
Provide a short and direct response. 0.06. What is the ratio of the Imports (BoP, current US$) in 2008 in Congo (Democratic) to that in Czech Republic?
Offer a terse response. 0.06. What is the ratio of the Imports (BoP, current US$) of 2005 in Costa Rica to that in Cyprus?
Provide a succinct answer. 0.91. What is the ratio of the Imports (BoP, current US$) of 2006 in Costa Rica to that in Cyprus?
Your response must be concise. 0.95. What is the ratio of the Imports (BoP, current US$) in 2007 in Costa Rica to that in Cyprus?
Your answer should be very brief. 0.92. What is the ratio of the Imports (BoP, current US$) in 2008 in Costa Rica to that in Cyprus?
Your answer should be compact. 0.91. What is the ratio of the Imports (BoP, current US$) in 2005 in Costa Rica to that in Czech Republic?
Ensure brevity in your answer.  0.11. What is the ratio of the Imports (BoP, current US$) of 2006 in Costa Rica to that in Czech Republic?
Offer a very short reply. 0.1. What is the ratio of the Imports (BoP, current US$) in 2007 in Costa Rica to that in Czech Republic?
Your response must be concise. 0.1. What is the ratio of the Imports (BoP, current US$) in 2008 in Costa Rica to that in Czech Republic?
Provide a short and direct response. 0.09. What is the ratio of the Imports (BoP, current US$) of 2005 in Cyprus to that in Czech Republic?
Your answer should be very brief. 0.12. What is the ratio of the Imports (BoP, current US$) in 2006 in Cyprus to that in Czech Republic?
Keep it short and to the point. 0.1. What is the ratio of the Imports (BoP, current US$) of 2007 in Cyprus to that in Czech Republic?
Offer a very short reply. 0.1. What is the ratio of the Imports (BoP, current US$) in 2008 in Cyprus to that in Czech Republic?
Ensure brevity in your answer.  0.1. What is the difference between the highest and the second highest Imports (BoP, current US$) in 2005?
Make the answer very short. 3.56e+1. What is the difference between the highest and the second highest Imports (BoP, current US$) of 2006?
Provide a short and direct response. 4.47e+1. What is the difference between the highest and the second highest Imports (BoP, current US$) of 2007?
Provide a short and direct response. 5.85e+1. What is the difference between the highest and the second highest Imports (BoP, current US$) of 2008?
Your response must be concise. 7.54e+1. What is the difference between the highest and the lowest Imports (BoP, current US$) of 2005?
Your answer should be very brief. 7.00e+1. What is the difference between the highest and the lowest Imports (BoP, current US$) of 2006?
Provide a short and direct response. 8.52e+1. What is the difference between the highest and the lowest Imports (BoP, current US$) of 2007?
Your answer should be compact. 1.06e+11. What is the difference between the highest and the lowest Imports (BoP, current US$) of 2008?
Give a very brief answer. 1.36e+11. 